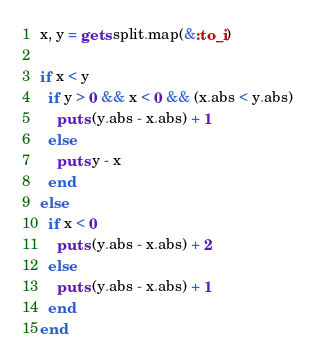<code> <loc_0><loc_0><loc_500><loc_500><_Ruby_>x, y = gets.split.map(&:to_i)

if x < y
  if y > 0 && x < 0 && (x.abs < y.abs)
    puts (y.abs - x.abs) + 1
  else
    puts y - x
  end
else
  if x < 0
    puts (y.abs - x.abs) + 2
  else
    puts (y.abs - x.abs) + 1
  end
end
</code> 